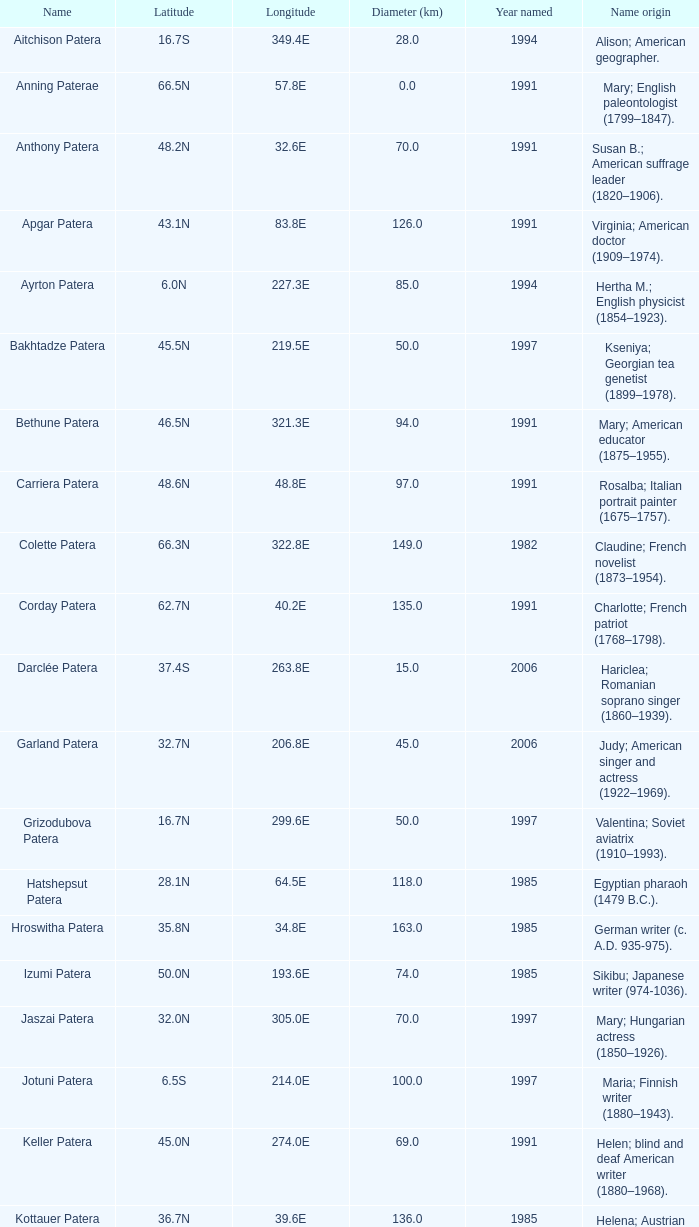What is the source of the name keller patera? Helen; blind and deaf American writer (1880–1968). 